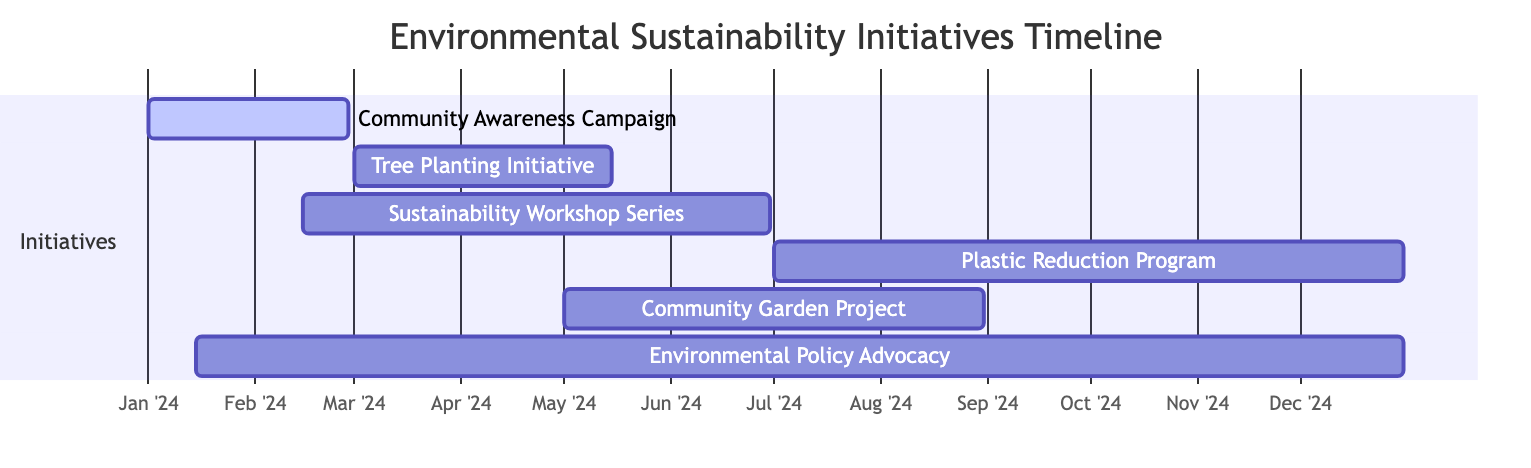What is the duration of the Community Awareness Campaign? The Community Awareness Campaign runs from January 1, 2024, to February 28, 2024. To find the duration, we subtract the start date from the end date, which gives us 58 days.
Answer: 58 days When does the Plastic Reduction Program start? According to the timeline, the Plastic Reduction Program starts on July 1, 2024. This date is indicated clearly on the Gantt chart.
Answer: July 1, 2024 Which initiative overlaps with the Environmental Policy Advocacy? The Environmental Policy Advocacy initiative runs from January 15, 2024, to December 31, 2024. It overlaps with the Community Awareness Campaign from January 1, 2024, to February 28, 2024, and the Sustainability Workshop Series from February 15, 2024, to June 30, 2024.
Answer: Community Awareness Campaign and Sustainability Workshop Series What is the latest end date for any initiative? The latest end date in the Gantt chart is December 31, 2024. This date corresponds to the Environmental Policy Advocacy initiative, which spans the entire year.
Answer: December 31, 2024 How many initiatives are scheduled to occur in the month of May 2024? In May 2024, there are two initiatives planned: the Tree Planting Initiative (from March 1 to May 15) and the Community Garden Project (from May 1 to August 31). Counting both, we have a total of two initiatives.
Answer: 2 Which initiative starts just after the Sustainability Workshop Series ends? The Sustainability Workshop Series ends on June 30, 2024. The next initiative that starts after this date is the Plastic Reduction Program, which begins on July 1, 2024.
Answer: Plastic Reduction Program What is the starting date of the Tree Planting Initiative? The Tree Planting Initiative starts on March 1, 2024, as indicated in the schedule of the Gantt chart. This information is directly represented in the timeline.
Answer: March 1, 2024 What tasks overlap in the month of April 2024? In April 2024, the Community Awareness Campaign (which ends February 28) has already concluded, and the Sustainability Workshop Series (which ends June 30) and the Tree Planting Initiative (which ends May 15) are both ongoing. Thus, the initiatives overlapping during this month are the Sustainability Workshop Series and the Tree Planting Initiative.
Answer: Sustainability Workshop Series and Tree Planting Initiative 